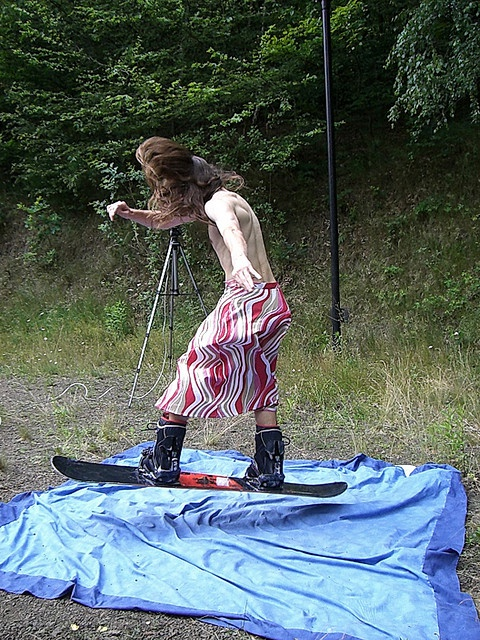Describe the objects in this image and their specific colors. I can see people in darkgreen, black, lavender, gray, and darkgray tones and snowboard in darkgreen, black, gray, and lavender tones in this image. 